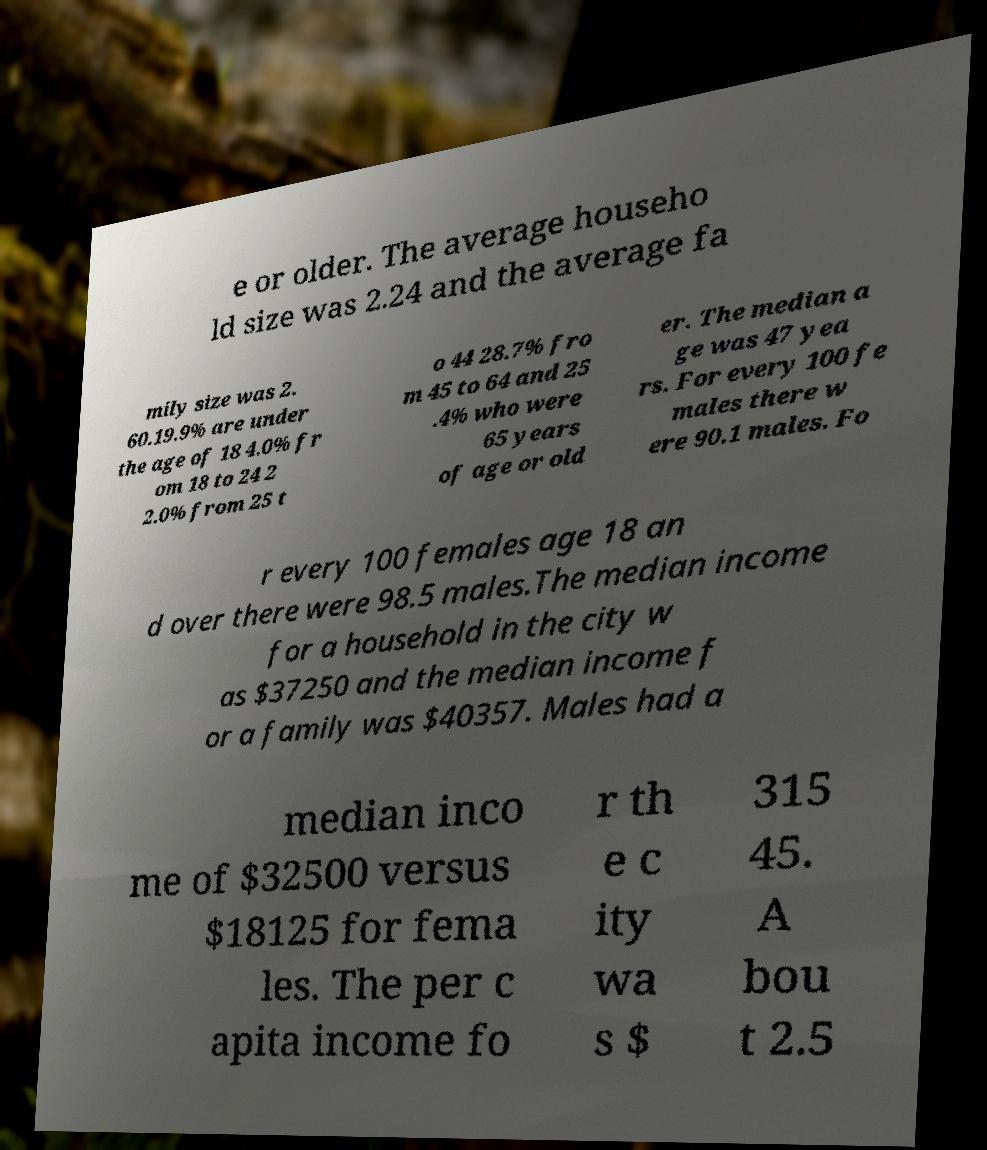What messages or text are displayed in this image? I need them in a readable, typed format. e or older. The average househo ld size was 2.24 and the average fa mily size was 2. 60.19.9% are under the age of 18 4.0% fr om 18 to 24 2 2.0% from 25 t o 44 28.7% fro m 45 to 64 and 25 .4% who were 65 years of age or old er. The median a ge was 47 yea rs. For every 100 fe males there w ere 90.1 males. Fo r every 100 females age 18 an d over there were 98.5 males.The median income for a household in the city w as $37250 and the median income f or a family was $40357. Males had a median inco me of $32500 versus $18125 for fema les. The per c apita income fo r th e c ity wa s $ 315 45. A bou t 2.5 